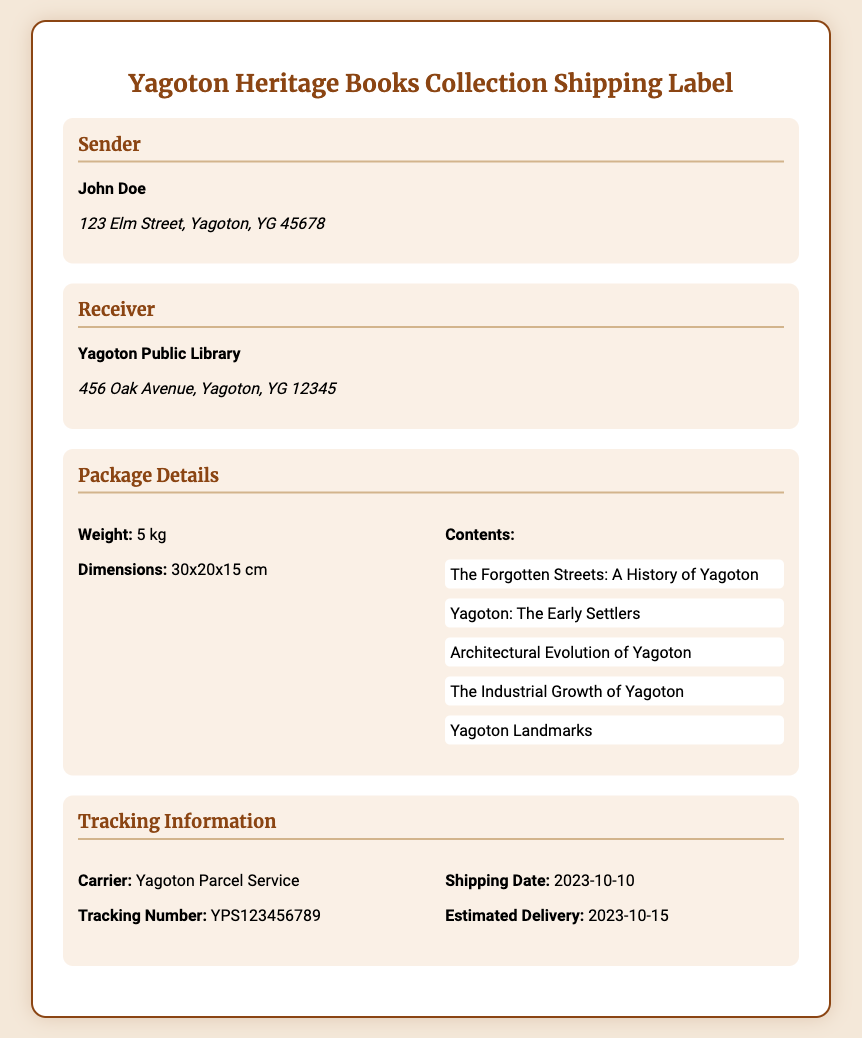What is the name of the sender? The sender's name is provided in the document under the Sender section.
Answer: John Doe What is the address of the receiver? The receiver's address is specified in the Receiver section of the document.
Answer: 456 Oak Avenue, Yagoton, YG 12345 What is the weight of the package? The weight of the package is mentioned in the Package Details section.
Answer: 5 kg What is the tracking number? The tracking number is listed under the Tracking Information section.
Answer: YPS123456789 When was the shipping date? The shipping date is provided in the Tracking Information section.
Answer: 2023-10-10 Which book is about the history of streets in Yagoton? The titles of the books included in the package are listed under the Package Details section.
Answer: The Forgotten Streets: A History of Yagoton What is the estimated delivery date? The estimated delivery date is mentioned in the Tracking Information section.
Answer: 2023-10-15 Who is the carrier for this shipment? The carrier's name can be found in the Tracking Information section of the document.
Answer: Yagoton Parcel Service What are the dimensions of the package? The dimensions of the package are provided in the Package Details section.
Answer: 30x20x15 cm 